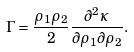Convert formula to latex. <formula><loc_0><loc_0><loc_500><loc_500>\Gamma = \frac { \rho _ { 1 } \rho _ { 2 } } { 2 } \frac { \partial ^ { 2 } \kappa } { \partial \rho _ { 1 } \partial \rho _ { 2 } } .</formula> 